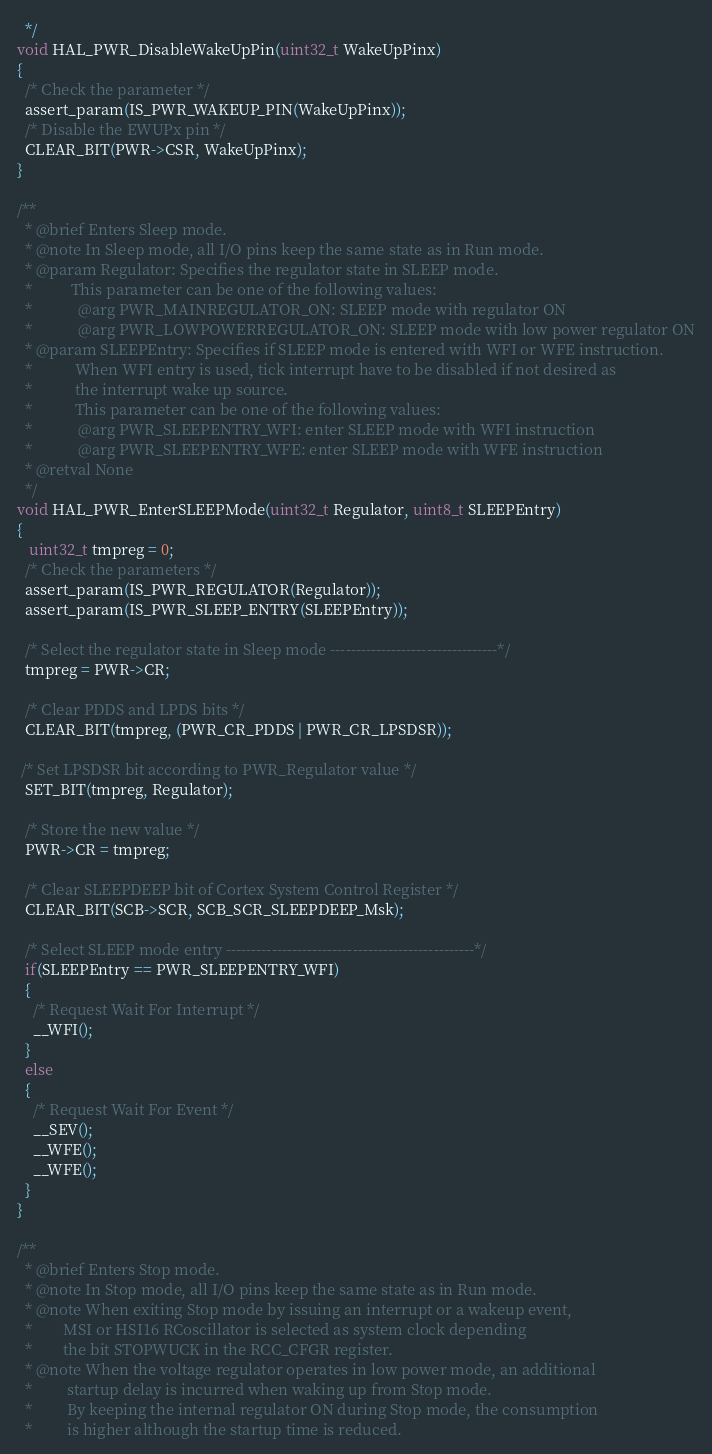<code> <loc_0><loc_0><loc_500><loc_500><_C_>  */
void HAL_PWR_DisableWakeUpPin(uint32_t WakeUpPinx)
{
  /* Check the parameter */
  assert_param(IS_PWR_WAKEUP_PIN(WakeUpPinx));
  /* Disable the EWUPx pin */
  CLEAR_BIT(PWR->CSR, WakeUpPinx);
}

/**
  * @brief Enters Sleep mode.
  * @note In Sleep mode, all I/O pins keep the same state as in Run mode.
  * @param Regulator: Specifies the regulator state in SLEEP mode.
  *          This parameter can be one of the following values:
  *            @arg PWR_MAINREGULATOR_ON: SLEEP mode with regulator ON
  *            @arg PWR_LOWPOWERREGULATOR_ON: SLEEP mode with low power regulator ON
  * @param SLEEPEntry: Specifies if SLEEP mode is entered with WFI or WFE instruction.
  *           When WFI entry is used, tick interrupt have to be disabled if not desired as 
  *           the interrupt wake up source.
  *           This parameter can be one of the following values:
  *            @arg PWR_SLEEPENTRY_WFI: enter SLEEP mode with WFI instruction
  *            @arg PWR_SLEEPENTRY_WFE: enter SLEEP mode with WFE instruction
  * @retval None
  */
void HAL_PWR_EnterSLEEPMode(uint32_t Regulator, uint8_t SLEEPEntry)
{
   uint32_t tmpreg = 0;
  /* Check the parameters */
  assert_param(IS_PWR_REGULATOR(Regulator));
  assert_param(IS_PWR_SLEEP_ENTRY(SLEEPEntry));

  /* Select the regulator state in Sleep mode ---------------------------------*/
  tmpreg = PWR->CR;

  /* Clear PDDS and LPDS bits */
  CLEAR_BIT(tmpreg, (PWR_CR_PDDS | PWR_CR_LPSDSR));

 /* Set LPSDSR bit according to PWR_Regulator value */
  SET_BIT(tmpreg, Regulator);

  /* Store the new value */
  PWR->CR = tmpreg;
  
  /* Clear SLEEPDEEP bit of Cortex System Control Register */
  CLEAR_BIT(SCB->SCR, SCB_SCR_SLEEPDEEP_Msk);

  /* Select SLEEP mode entry -------------------------------------------------*/
  if(SLEEPEntry == PWR_SLEEPENTRY_WFI)
  {
    /* Request Wait For Interrupt */
    __WFI();
  }
  else
  {
    /* Request Wait For Event */
    __SEV();
    __WFE();
    __WFE();
  }
}

/**
  * @brief Enters Stop mode. 
  * @note In Stop mode, all I/O pins keep the same state as in Run mode.
  * @note When exiting Stop mode by issuing an interrupt or a wakeup event,
  *        MSI or HSI16 RCoscillator is selected as system clock depending 
  *        the bit STOPWUCK in the RCC_CFGR register.
  * @note When the voltage regulator operates in low power mode, an additional
  *         startup delay is incurred when waking up from Stop mode. 
  *         By keeping the internal regulator ON during Stop mode, the consumption
  *         is higher although the startup time is reduced.</code> 